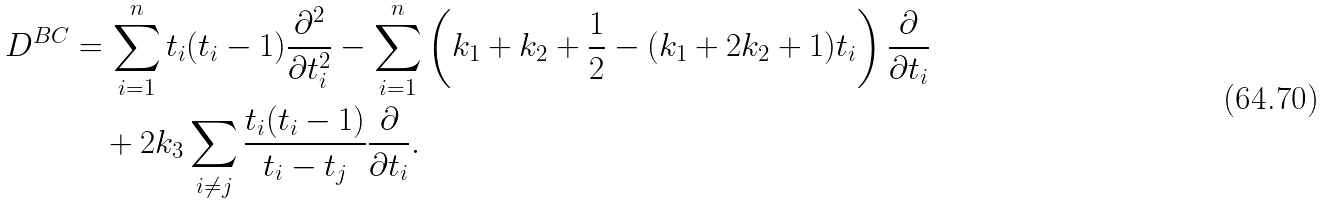Convert formula to latex. <formula><loc_0><loc_0><loc_500><loc_500>D ^ { B C } & = \sum _ { i = 1 } ^ { n } t _ { i } ( t _ { i } - 1 ) \frac { \partial ^ { 2 } } { \partial t _ { i } ^ { 2 } } - \sum _ { i = 1 } ^ { n } \left ( k _ { 1 } + k _ { 2 } + \frac { 1 } { 2 } - ( k _ { 1 } + 2 k _ { 2 } + 1 ) t _ { i } \right ) \frac { \partial } { \partial t _ { i } } \\ & \quad + 2 k _ { 3 } \sum _ { i \neq j } \frac { t _ { i } ( t _ { i } - 1 ) } { t _ { i } - t _ { j } } \frac { \partial } { \partial t _ { i } } .</formula> 